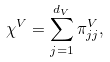Convert formula to latex. <formula><loc_0><loc_0><loc_500><loc_500>\chi ^ { V } = \sum _ { j = 1 } ^ { d _ { V } } \pi ^ { V } _ { j j } ,</formula> 